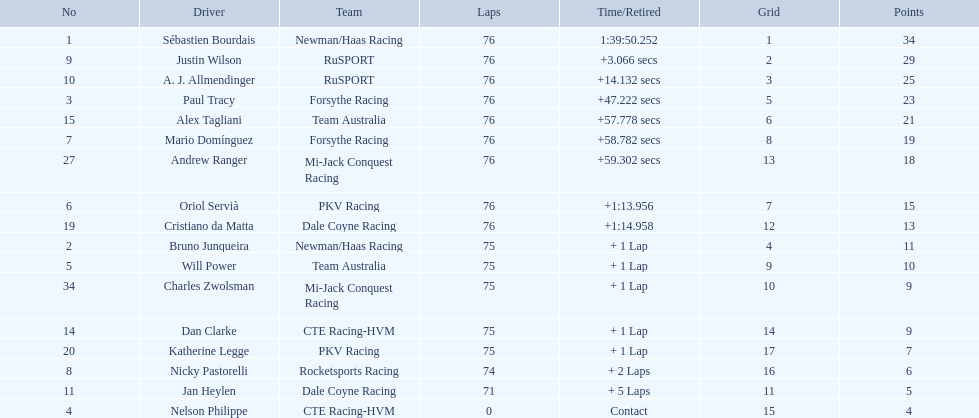Can you parse all the data within this table? {'header': ['No', 'Driver', 'Team', 'Laps', 'Time/Retired', 'Grid', 'Points'], 'rows': [['1', 'Sébastien Bourdais', 'Newman/Haas Racing', '76', '1:39:50.252', '1', '34'], ['9', 'Justin Wilson', 'RuSPORT', '76', '+3.066 secs', '2', '29'], ['10', 'A. J. Allmendinger', 'RuSPORT', '76', '+14.132 secs', '3', '25'], ['3', 'Paul Tracy', 'Forsythe Racing', '76', '+47.222 secs', '5', '23'], ['15', 'Alex Tagliani', 'Team Australia', '76', '+57.778 secs', '6', '21'], ['7', 'Mario Domínguez', 'Forsythe Racing', '76', '+58.782 secs', '8', '19'], ['27', 'Andrew Ranger', 'Mi-Jack Conquest Racing', '76', '+59.302 secs', '13', '18'], ['6', 'Oriol Servià', 'PKV Racing', '76', '+1:13.956', '7', '15'], ['19', 'Cristiano da Matta', 'Dale Coyne Racing', '76', '+1:14.958', '12', '13'], ['2', 'Bruno Junqueira', 'Newman/Haas Racing', '75', '+ 1 Lap', '4', '11'], ['5', 'Will Power', 'Team Australia', '75', '+ 1 Lap', '9', '10'], ['34', 'Charles Zwolsman', 'Mi-Jack Conquest Racing', '75', '+ 1 Lap', '10', '9'], ['14', 'Dan Clarke', 'CTE Racing-HVM', '75', '+ 1 Lap', '14', '9'], ['20', 'Katherine Legge', 'PKV Racing', '75', '+ 1 Lap', '17', '7'], ['8', 'Nicky Pastorelli', 'Rocketsports Racing', '74', '+ 2 Laps', '16', '6'], ['11', 'Jan Heylen', 'Dale Coyne Racing', '71', '+ 5 Laps', '11', '5'], ['4', 'Nelson Philippe', 'CTE Racing-HVM', '0', 'Contact', '15', '4']]} What was the total points that canada earned together? 62. 